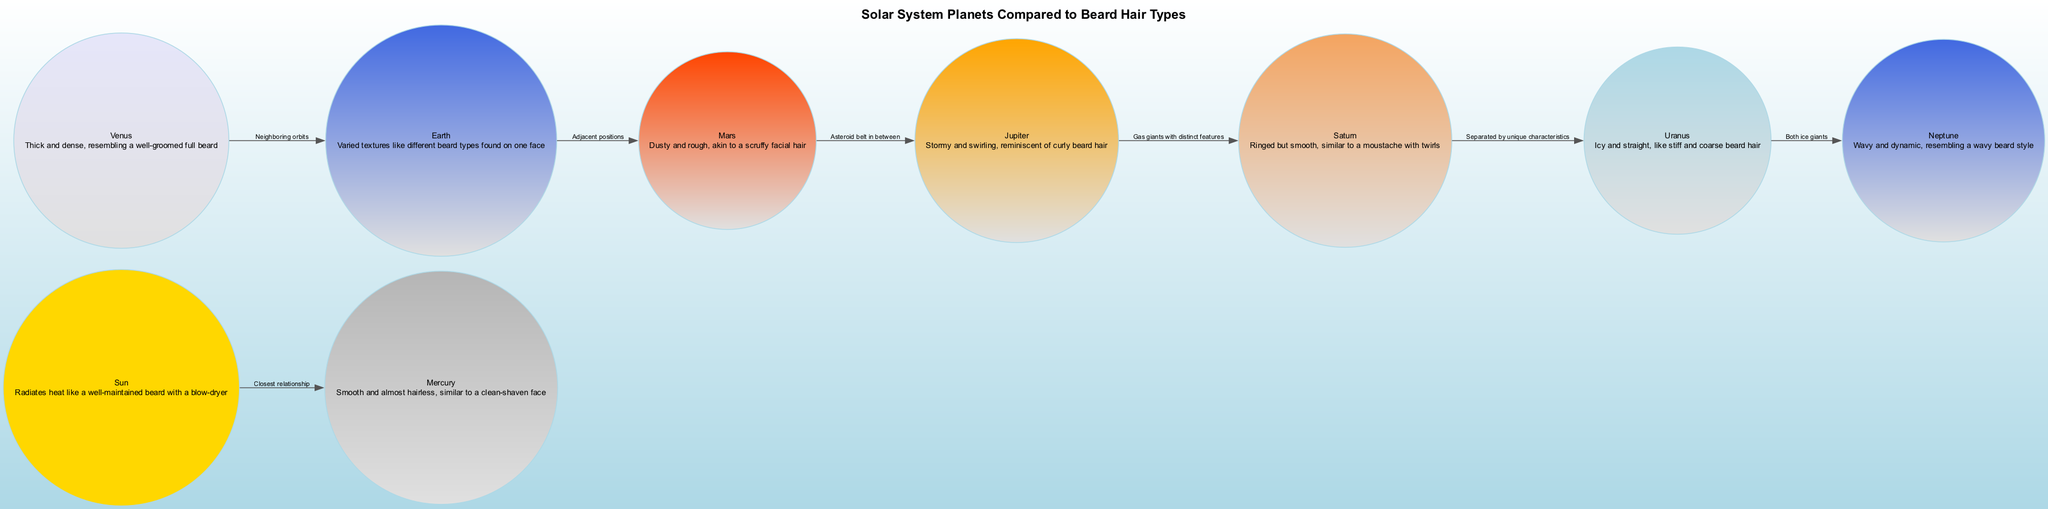What is the description of Earth? The description of Earth can be found by locating its node in the diagram, which states, "Varied textures like different beard types found on one face."
Answer: Varied textures like different beard types found on one face How many planets are compared to beard types? By counting the nodes in the diagram that represent planets, we see that there are eight: Sun, Mercury, Venus, Earth, Mars, Jupiter, Saturn, Uranus, and Neptune.
Answer: Eight Which planet resembles a well-groomed full beard? By analyzing the planets' descriptions, Venus is mentioned as "Thick and dense, resembling a well-groomed full beard."
Answer: Venus What is the relationship between Jupiter and Saturn? The edge labels between Jupiter and Saturn indicate their relationship, labeled as "Gas giants with distinct features."
Answer: Gas giants with distinct features Which planet has a description similar to a scruffy facial hair? The description of Mars states, "Dusty and rough, akin to a scruffy facial hair," making it the answer.
Answer: Mars What is the description of Saturn? Looking at Saturn's node, its description is "Ringed but smooth, similar to a moustache with twirls."
Answer: Ringed but smooth, similar to a moustache with twirls How are Uranus and Neptune categorized in the diagram? The edge label between Uranus and Neptune highlights that they are both "ice giants," indicating their category.
Answer: Ice giants What planet has a description that indicates it is like stiff and coarse beard hair? The node for Uranus states, "Icy and straight, like stiff and coarse beard hair," thus indicating its texture.
Answer: Uranus 